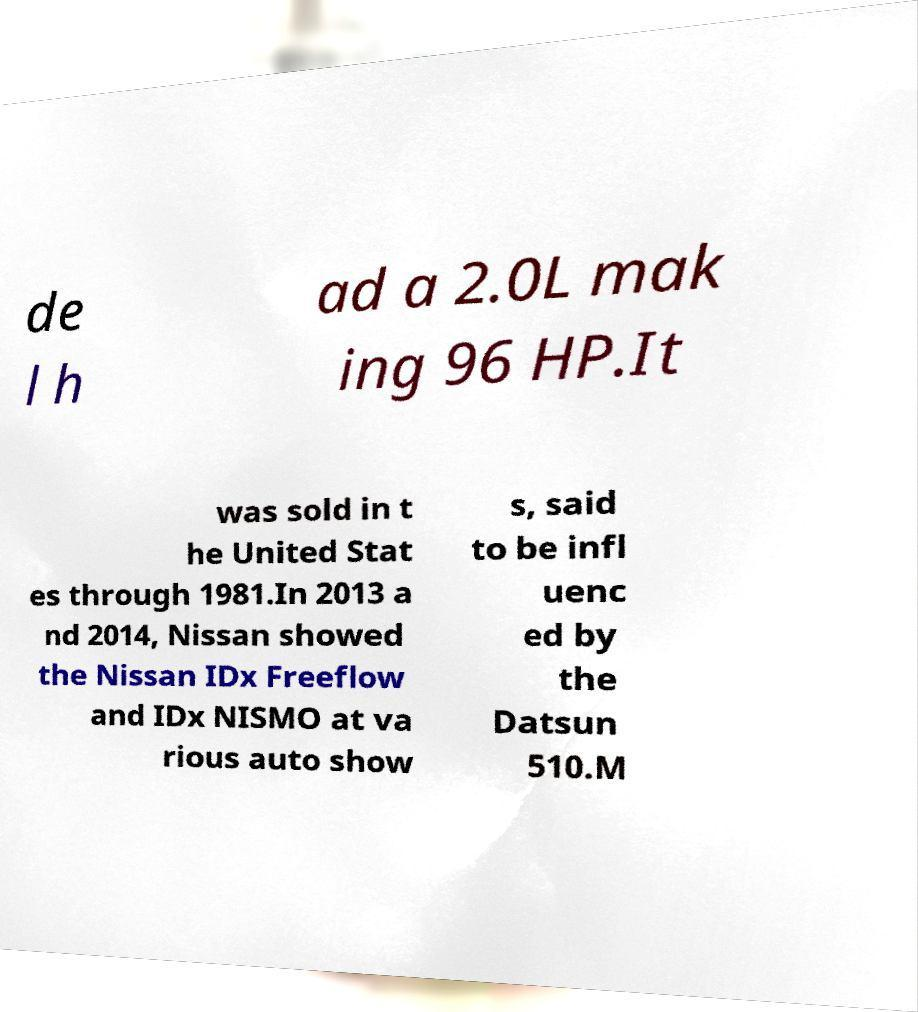Can you accurately transcribe the text from the provided image for me? de l h ad a 2.0L mak ing 96 HP.It was sold in t he United Stat es through 1981.In 2013 a nd 2014, Nissan showed the Nissan IDx Freeflow and IDx NISMO at va rious auto show s, said to be infl uenc ed by the Datsun 510.M 